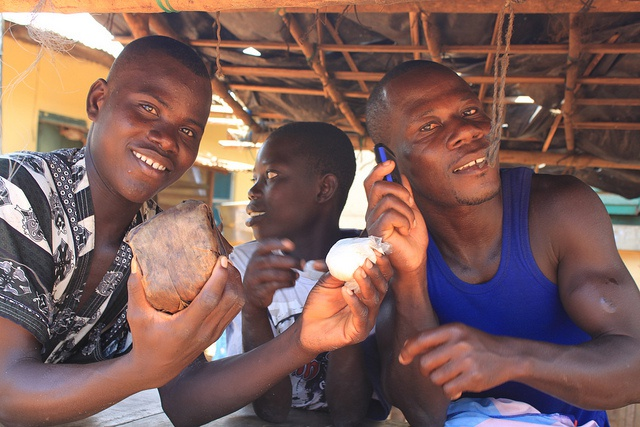Describe the objects in this image and their specific colors. I can see people in orange, brown, gray, black, and maroon tones, people in orange, brown, maroon, and navy tones, people in orange, black, brown, and lavender tones, and cell phone in orange, black, gray, and blue tones in this image. 